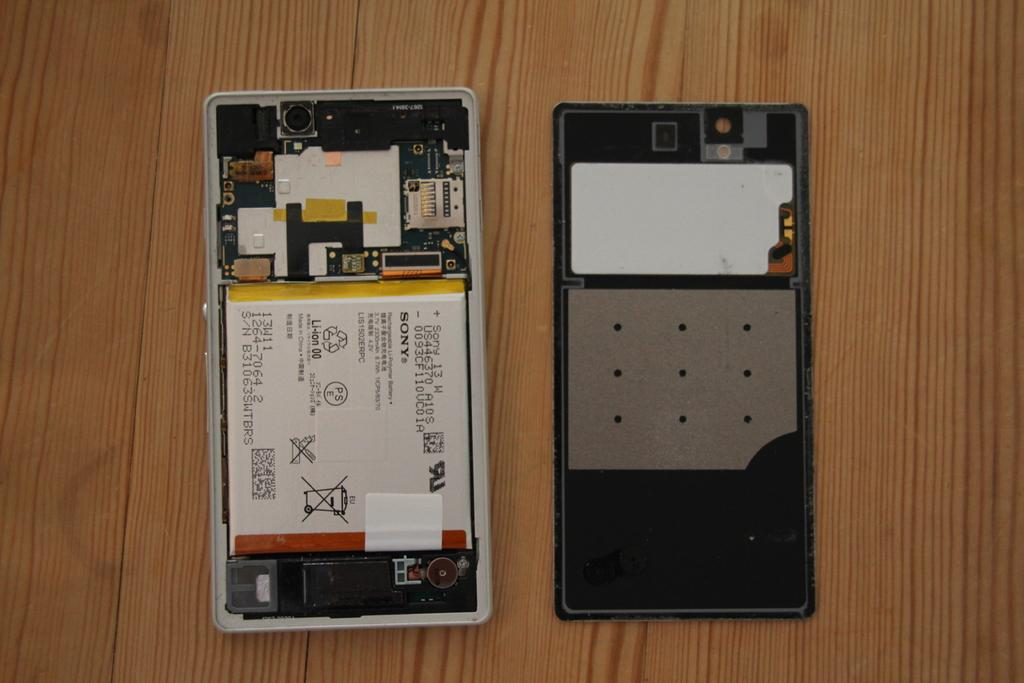Provide a one-sentence caption for the provided image. A cellphone is opened up revealing its insides, and a battery pack made by Sony. 